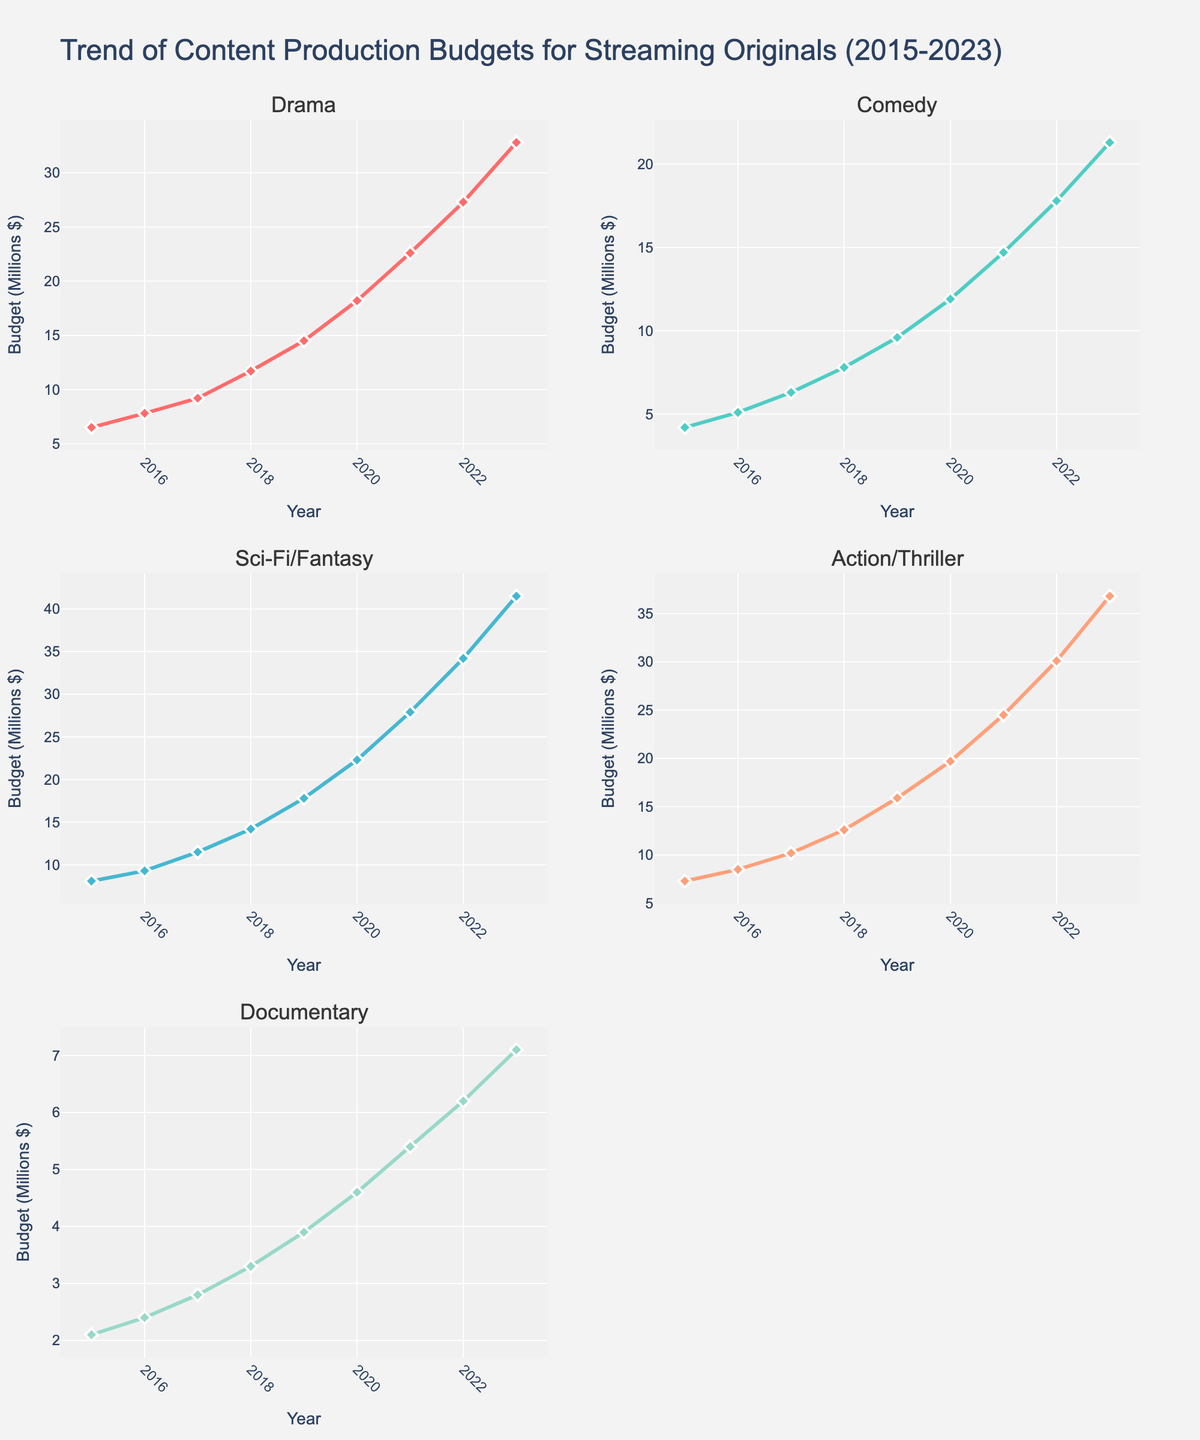What is the title of the figure? The title is displayed at the top of the figure, which describes the overall content and time span of the data.
Answer: Trend of Content Production Budgets for Streaming Originals (2015-2023) Which genre had the highest budget in 2023? By looking at the data points in 2023 across all the subplots, the highest value corresponds to the Sci-Fi/Fantasy genre.
Answer: Sci-Fi/Fantasy How has the budget for documentaries changed from 2015 to 2023? The budget for documentaries has increased each year. It started at $2.1 million in 2015 and reached $7.1 million in 2023, as seen by the upward trend line in the Documentary subplot.
Answer: Increased What was the average budget for Action/Thriller from 2015 to 2023? Sum the yearly budgets for Action/Thriller (7.3, 8.5, 10.2, 12.6, 15.9, 19.7, 24.5, 30.1, 36.8), then divide by 9 to find the average.
Answer: (7.3 + 8.5 + 10.2 + 12.6 + 15.9 + 19.7 + 24.5 + 30.1 + 36.8) / 9 = 185.6 / 9 = 20.62 Which genre saw the largest increase in budget from 2015 to 2023? Calculate the difference between the budgets in 2023 and 2015 for each genre. Sci-Fi/Fantasy had the largest increase from $8.1 million in 2015 to $41.5 million in 2023.
Answer: Sci-Fi/Fantasy Was there any year when Comedy budgets exceeded Drama budgets? By comparing the lines for each year, at no point does the budget for Comedy exceed the budget for Drama within the time span.
Answer: No Between Drama and Action/Thriller, which had a more consistent annual increase in budget? Observing the trends, the increase in Drama budgets each year is more consistent compared to Action/Thriller, which shows steeper increases in certain periods.
Answer: Drama Which two genres had the closest budget in 2018? Look at the subplot data points for 2018; Comedy and Documentary had the closest budgets at $7.8 million and $3.3 million respectively.
Answer: Comedy and Documentary In 2020, which genre had a budget closest to $20 million? By examining the data points for 2020, the budget for Action/Thriller ($19.7 million) is closest to $20 million.
Answer: Action/Thriller 